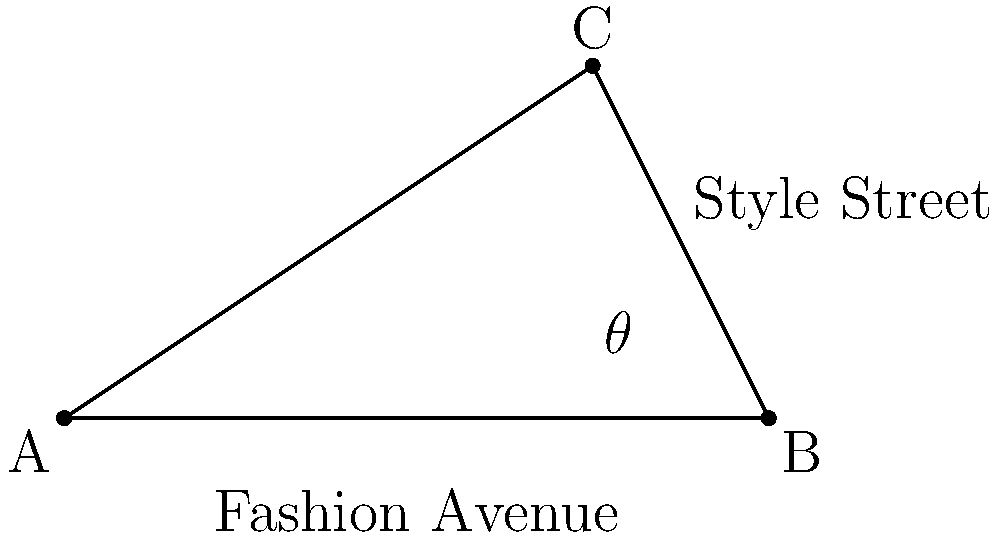Two popular shopping streets, Fashion Avenue and Style Street, intersect at point B as shown in the diagram. The coordinates of three fashion stores are given: A(0,0), B(4,0), and C(3,2). Calculate the angle $\theta$ between these two streets. To find the angle between the two streets, we can use the dot product formula for vectors. Let's approach this step-by-step:

1) First, we need to create vectors for each street:
   Vector $\vec{BA} = (0-4, 0-0) = (-4, 0)$
   Vector $\vec{BC} = (3-4, 2-0) = (-1, 2)$

2) The dot product formula for the angle between two vectors is:
   $$\cos\theta = \frac{\vec{a} \cdot \vec{b}}{|\vec{a}||\vec{b}|}$$

3) Let's calculate the dot product $\vec{BA} \cdot \vec{BC}$:
   $(-4, 0) \cdot (-1, 2) = 4 + 0 = 4$

4) Now, let's calculate the magnitudes:
   $|\vec{BA}| = \sqrt{(-4)^2 + 0^2} = 4$
   $|\vec{BC}| = \sqrt{(-1)^2 + 2^2} = \sqrt{5}$

5) Plugging these into our formula:
   $$\cos\theta = \frac{4}{4\sqrt{5}} = \frac{1}{\sqrt{5}}$$

6) To get $\theta$, we need to take the inverse cosine (arccos):
   $$\theta = \arccos(\frac{1}{\sqrt{5}})$$

7) Using a calculator or computer, we can evaluate this:
   $\theta \approx 63.4°$
Answer: $63.4°$ 